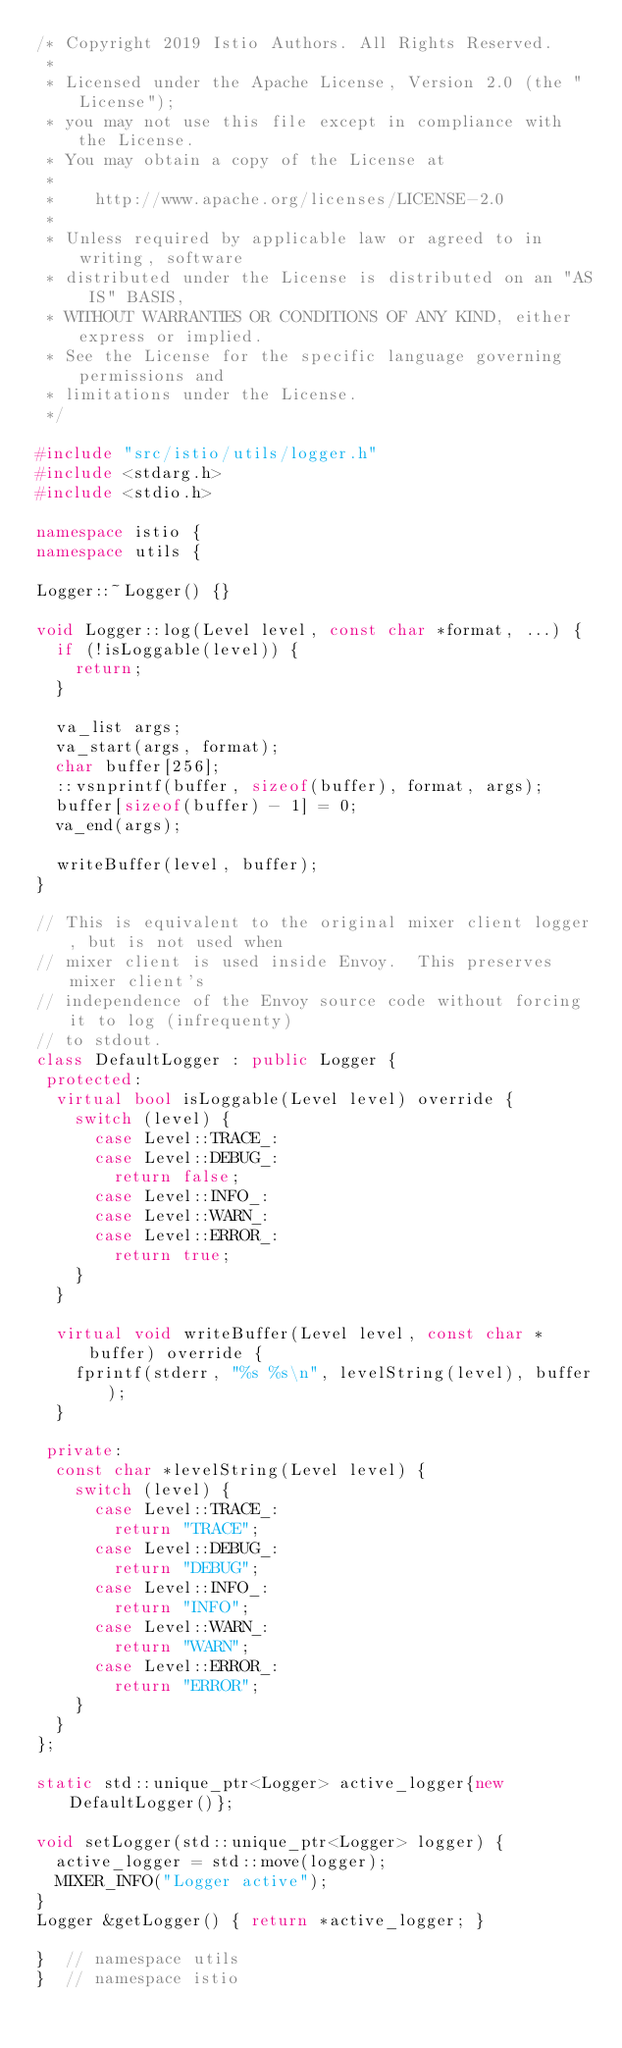Convert code to text. <code><loc_0><loc_0><loc_500><loc_500><_C++_>/* Copyright 2019 Istio Authors. All Rights Reserved.
 *
 * Licensed under the Apache License, Version 2.0 (the "License");
 * you may not use this file except in compliance with the License.
 * You may obtain a copy of the License at
 *
 *    http://www.apache.org/licenses/LICENSE-2.0
 *
 * Unless required by applicable law or agreed to in writing, software
 * distributed under the License is distributed on an "AS IS" BASIS,
 * WITHOUT WARRANTIES OR CONDITIONS OF ANY KIND, either express or implied.
 * See the License for the specific language governing permissions and
 * limitations under the License.
 */

#include "src/istio/utils/logger.h"
#include <stdarg.h>
#include <stdio.h>

namespace istio {
namespace utils {

Logger::~Logger() {}

void Logger::log(Level level, const char *format, ...) {
  if (!isLoggable(level)) {
    return;
  }

  va_list args;
  va_start(args, format);
  char buffer[256];
  ::vsnprintf(buffer, sizeof(buffer), format, args);
  buffer[sizeof(buffer) - 1] = 0;
  va_end(args);

  writeBuffer(level, buffer);
}

// This is equivalent to the original mixer client logger, but is not used when
// mixer client is used inside Envoy.  This preserves mixer client's
// independence of the Envoy source code without forcing it to log (infrequenty)
// to stdout.
class DefaultLogger : public Logger {
 protected:
  virtual bool isLoggable(Level level) override {
    switch (level) {
      case Level::TRACE_:
      case Level::DEBUG_:
        return false;
      case Level::INFO_:
      case Level::WARN_:
      case Level::ERROR_:
        return true;
    }
  }

  virtual void writeBuffer(Level level, const char *buffer) override {
    fprintf(stderr, "%s %s\n", levelString(level), buffer);
  }

 private:
  const char *levelString(Level level) {
    switch (level) {
      case Level::TRACE_:
        return "TRACE";
      case Level::DEBUG_:
        return "DEBUG";
      case Level::INFO_:
        return "INFO";
      case Level::WARN_:
        return "WARN";
      case Level::ERROR_:
        return "ERROR";
    }
  }
};

static std::unique_ptr<Logger> active_logger{new DefaultLogger()};

void setLogger(std::unique_ptr<Logger> logger) {
  active_logger = std::move(logger);
  MIXER_INFO("Logger active");
}
Logger &getLogger() { return *active_logger; }

}  // namespace utils
}  // namespace istio
</code> 